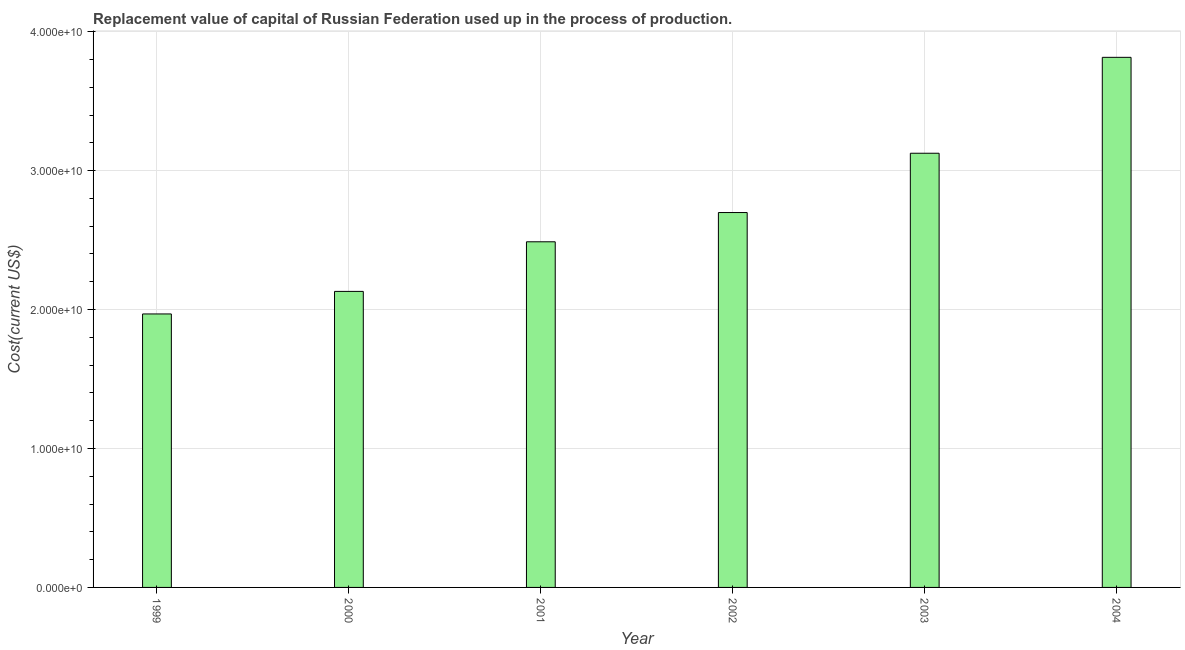What is the title of the graph?
Keep it short and to the point. Replacement value of capital of Russian Federation used up in the process of production. What is the label or title of the X-axis?
Make the answer very short. Year. What is the label or title of the Y-axis?
Your answer should be very brief. Cost(current US$). What is the consumption of fixed capital in 2002?
Your answer should be very brief. 2.70e+1. Across all years, what is the maximum consumption of fixed capital?
Your answer should be compact. 3.82e+1. Across all years, what is the minimum consumption of fixed capital?
Ensure brevity in your answer.  1.97e+1. In which year was the consumption of fixed capital maximum?
Your answer should be very brief. 2004. What is the sum of the consumption of fixed capital?
Ensure brevity in your answer.  1.62e+11. What is the difference between the consumption of fixed capital in 1999 and 2001?
Ensure brevity in your answer.  -5.19e+09. What is the average consumption of fixed capital per year?
Offer a terse response. 2.70e+1. What is the median consumption of fixed capital?
Make the answer very short. 2.59e+1. In how many years, is the consumption of fixed capital greater than 36000000000 US$?
Keep it short and to the point. 1. What is the ratio of the consumption of fixed capital in 2000 to that in 2004?
Your answer should be compact. 0.56. Is the consumption of fixed capital in 2002 less than that in 2004?
Provide a short and direct response. Yes. What is the difference between the highest and the second highest consumption of fixed capital?
Your response must be concise. 6.90e+09. Is the sum of the consumption of fixed capital in 2002 and 2003 greater than the maximum consumption of fixed capital across all years?
Your answer should be compact. Yes. What is the difference between the highest and the lowest consumption of fixed capital?
Your response must be concise. 1.85e+1. In how many years, is the consumption of fixed capital greater than the average consumption of fixed capital taken over all years?
Your answer should be compact. 2. Are all the bars in the graph horizontal?
Provide a short and direct response. No. How many years are there in the graph?
Offer a terse response. 6. Are the values on the major ticks of Y-axis written in scientific E-notation?
Give a very brief answer. Yes. What is the Cost(current US$) of 1999?
Offer a terse response. 1.97e+1. What is the Cost(current US$) of 2000?
Provide a short and direct response. 2.13e+1. What is the Cost(current US$) in 2001?
Give a very brief answer. 2.49e+1. What is the Cost(current US$) of 2002?
Ensure brevity in your answer.  2.70e+1. What is the Cost(current US$) in 2003?
Offer a very short reply. 3.12e+1. What is the Cost(current US$) in 2004?
Your answer should be compact. 3.82e+1. What is the difference between the Cost(current US$) in 1999 and 2000?
Keep it short and to the point. -1.62e+09. What is the difference between the Cost(current US$) in 1999 and 2001?
Offer a terse response. -5.19e+09. What is the difference between the Cost(current US$) in 1999 and 2002?
Offer a terse response. -7.30e+09. What is the difference between the Cost(current US$) in 1999 and 2003?
Keep it short and to the point. -1.16e+1. What is the difference between the Cost(current US$) in 1999 and 2004?
Give a very brief answer. -1.85e+1. What is the difference between the Cost(current US$) in 2000 and 2001?
Give a very brief answer. -3.57e+09. What is the difference between the Cost(current US$) in 2000 and 2002?
Provide a short and direct response. -5.68e+09. What is the difference between the Cost(current US$) in 2000 and 2003?
Give a very brief answer. -9.94e+09. What is the difference between the Cost(current US$) in 2000 and 2004?
Your answer should be very brief. -1.68e+1. What is the difference between the Cost(current US$) in 2001 and 2002?
Make the answer very short. -2.10e+09. What is the difference between the Cost(current US$) in 2001 and 2003?
Your response must be concise. -6.37e+09. What is the difference between the Cost(current US$) in 2001 and 2004?
Your response must be concise. -1.33e+1. What is the difference between the Cost(current US$) in 2002 and 2003?
Give a very brief answer. -4.27e+09. What is the difference between the Cost(current US$) in 2002 and 2004?
Ensure brevity in your answer.  -1.12e+1. What is the difference between the Cost(current US$) in 2003 and 2004?
Give a very brief answer. -6.90e+09. What is the ratio of the Cost(current US$) in 1999 to that in 2000?
Make the answer very short. 0.92. What is the ratio of the Cost(current US$) in 1999 to that in 2001?
Your response must be concise. 0.79. What is the ratio of the Cost(current US$) in 1999 to that in 2002?
Provide a short and direct response. 0.73. What is the ratio of the Cost(current US$) in 1999 to that in 2003?
Your response must be concise. 0.63. What is the ratio of the Cost(current US$) in 1999 to that in 2004?
Your answer should be very brief. 0.52. What is the ratio of the Cost(current US$) in 2000 to that in 2001?
Provide a succinct answer. 0.86. What is the ratio of the Cost(current US$) in 2000 to that in 2002?
Offer a very short reply. 0.79. What is the ratio of the Cost(current US$) in 2000 to that in 2003?
Make the answer very short. 0.68. What is the ratio of the Cost(current US$) in 2000 to that in 2004?
Provide a short and direct response. 0.56. What is the ratio of the Cost(current US$) in 2001 to that in 2002?
Your answer should be very brief. 0.92. What is the ratio of the Cost(current US$) in 2001 to that in 2003?
Ensure brevity in your answer.  0.8. What is the ratio of the Cost(current US$) in 2001 to that in 2004?
Offer a very short reply. 0.65. What is the ratio of the Cost(current US$) in 2002 to that in 2003?
Your response must be concise. 0.86. What is the ratio of the Cost(current US$) in 2002 to that in 2004?
Offer a terse response. 0.71. What is the ratio of the Cost(current US$) in 2003 to that in 2004?
Your response must be concise. 0.82. 